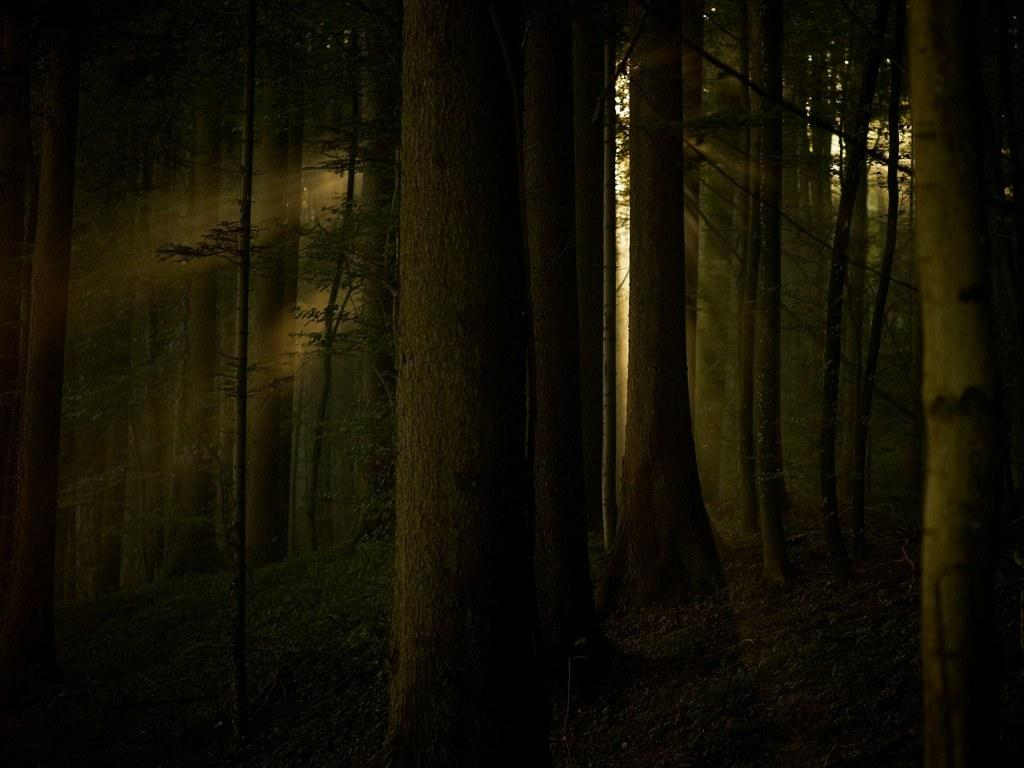What type of vegetation can be seen in the image? There are trees in the image. What is visible on the ground in the image? The ground is visible in the image, and there is grass on it. What can be seen coming from the sky in the image? Sun rays are visible in the image. What type of stove is visible in the image? There is no stove present in the image. Can you see an airplane flying in the image? There is no airplane visible in the image. 